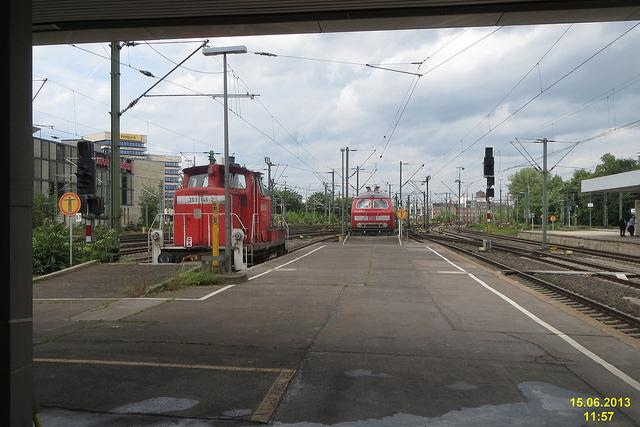How many years back the photograph was taken?

Choices:
A) ten
B) eight
C) five
D) seven eight 